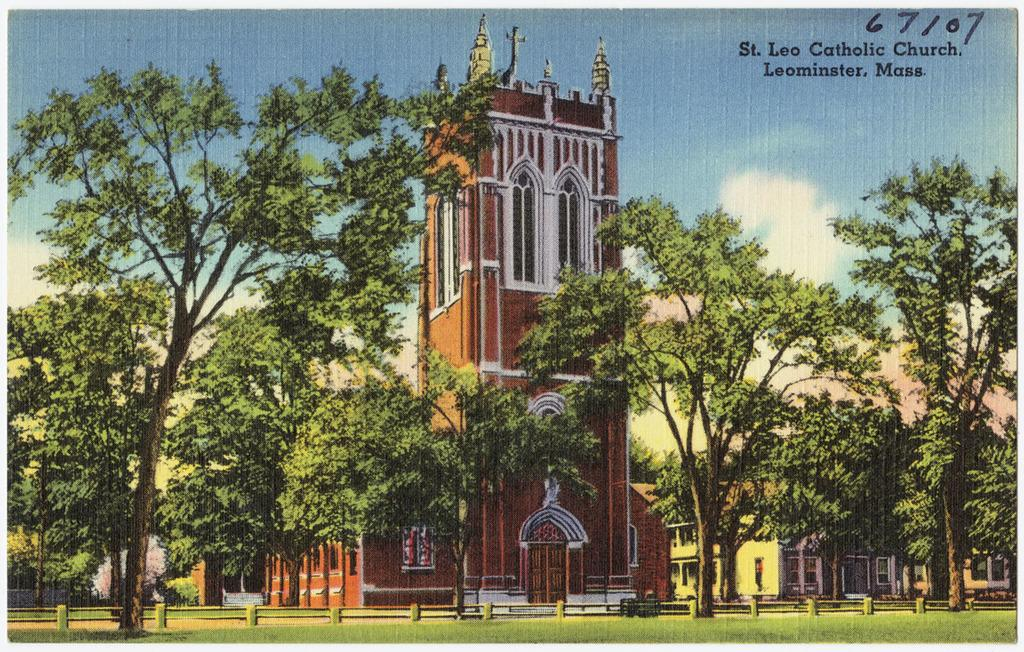<image>
Share a concise interpretation of the image provided. A postcard illustration of a church that says St. Lee Catholic Church, Leominster, Mass. in the corner. 